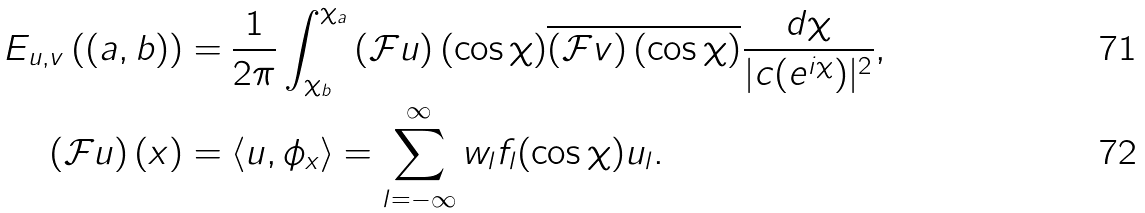<formula> <loc_0><loc_0><loc_500><loc_500>E _ { u , v } \left ( ( a , b ) \right ) & = \frac { 1 } { 2 \pi } \int _ { \chi _ { b } } ^ { \chi _ { a } } \left ( { \mathcal { F } } u \right ) ( \cos \chi ) \overline { \left ( { \mathcal { F } } v \right ) ( \cos \chi ) } \frac { d \chi } { | c ( e ^ { i \chi } ) | ^ { 2 } } , \\ \left ( { \mathcal { F } } u \right ) ( x ) & = \langle u , \phi _ { x } \rangle = \sum _ { l = - \infty } ^ { \infty } w _ { l } f _ { l } ( \cos \chi ) u _ { l } .</formula> 